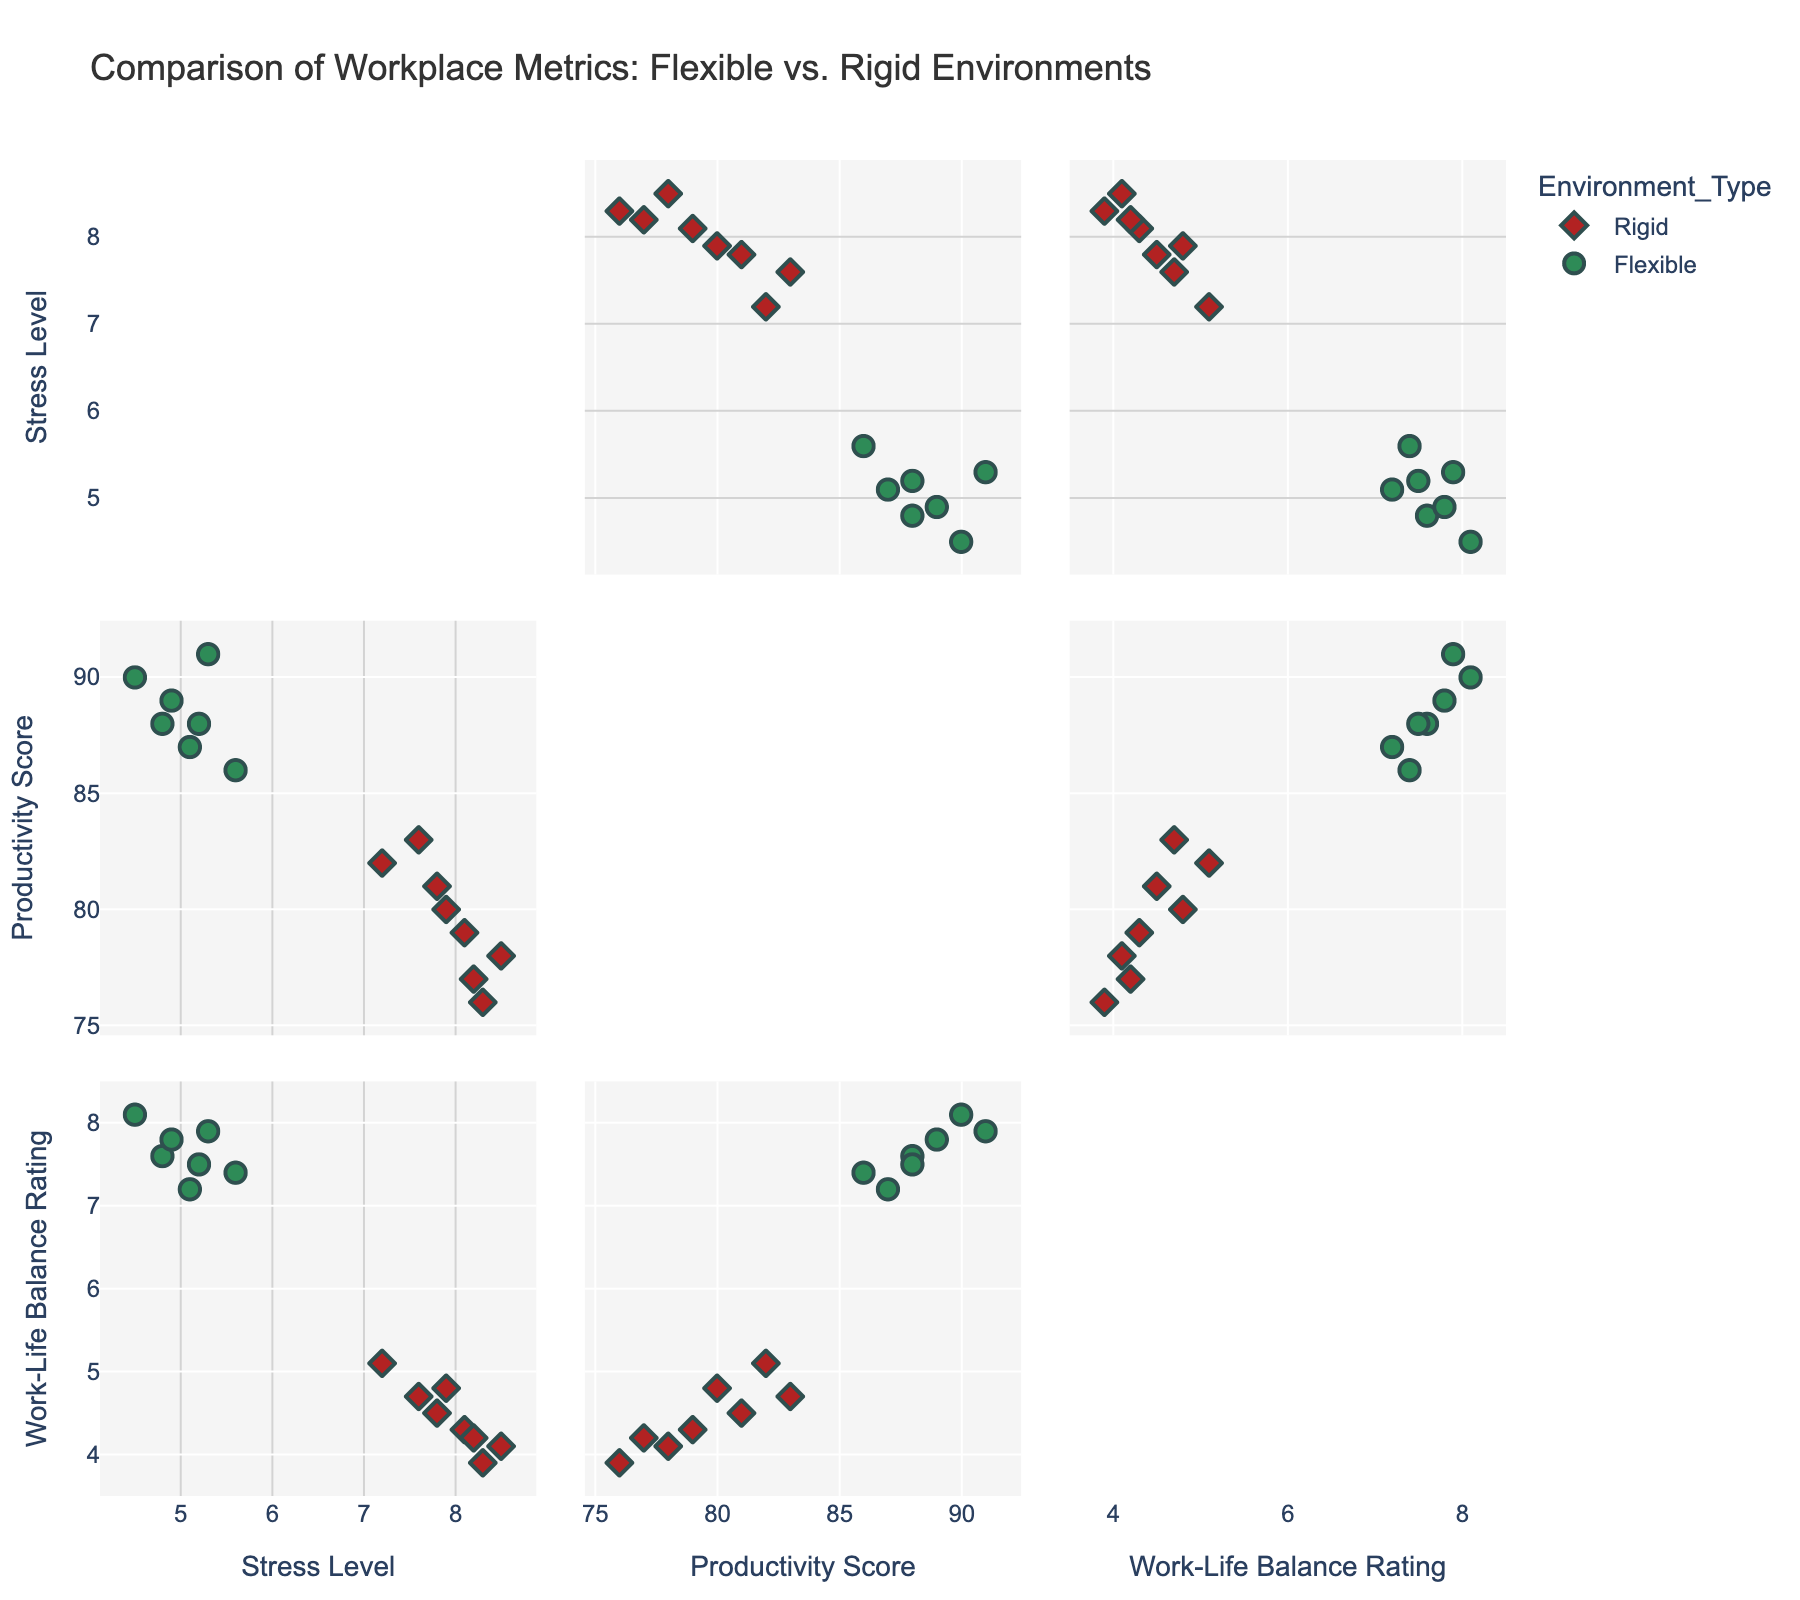What is the title of the figure? The title is usually displayed at the top of the figure and provides a brief description of the content or purpose of the chart. In this case, you can see the title clearly at the top of the scatterplot matrix.
Answer: Comparison of Workplace Metrics: Flexible vs. Rigid Environments How many total data points are represented in the scatterplot matrix? To find the total number of data points, count all the points visible in the scatterplot matrix, regardless of their color or shape. Each point corresponds to a workplace from the dataset.
Answer: 15 What color represents the 'Flexible' work environments? Look at the legend or the data points in the scatterplot matrix. The colors are used to differentiate between the types of work environments.
Answer: Green What color represents the 'Rigid' work environments? Similar to the previous question, check the legend or the data points to identify the color used for 'Rigid' work environments.
Answer: Red How many dimensions are plotted in the scatterplot matrix? A scatterplot matrix typically displays multiple dimensions (variables). Count the number of unique axes or labels along the rows and columns.
Answer: 3 Which environment type tends to have higher work-life balance ratings? Observe the distribution of data points along the 'Work-Life Balance Rating' axis. Check which color, representing a specific environment type, generally clusters towards higher values.
Answer: Flexible What is the average productivity score for 'Flexible' work environments? Identify the data points corresponding to 'Flexible' work environments, look at their productivity scores, sum them up, and then divide by the number of data points. Scores for Flexible are 88, 91, 87, 90, 86, 89, 88.
Answer: (88+91+87+90+86+89+88)/7 = 88.43 Which environment type shows a higher stress level on average? Compare the average stress levels for both environment types by calculating the mean for each. Sum the stress levels for each environment type and divide by the number of data points in each group.
Answer: Rigid Are there any data points that simultaneously have high productivity scores and low work-life balance ratings? Scan for points that are located in the upper range of 'Productivity Score' but lower range of 'Work-Life Balance Rating' within the same panel.
Answer: Yes, points from Rigid environments Which environment type has more variability in work-life balance ratings? Check the spread of data points along the 'Work-Life Balance Rating' axis for both environment types. More spread indicates higher variability.
Answer: Rigid 